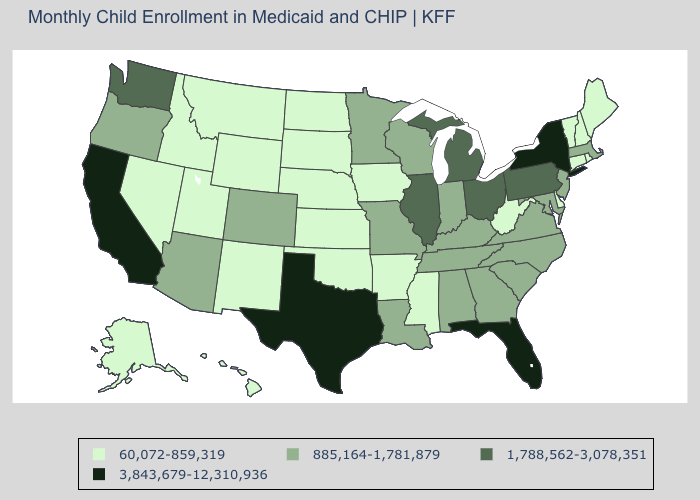What is the value of Minnesota?
Keep it brief. 885,164-1,781,879. Which states have the lowest value in the USA?
Short answer required. Alaska, Arkansas, Connecticut, Delaware, Hawaii, Idaho, Iowa, Kansas, Maine, Mississippi, Montana, Nebraska, Nevada, New Hampshire, New Mexico, North Dakota, Oklahoma, Rhode Island, South Dakota, Utah, Vermont, West Virginia, Wyoming. How many symbols are there in the legend?
Be succinct. 4. What is the value of Arkansas?
Write a very short answer. 60,072-859,319. What is the highest value in states that border Rhode Island?
Concise answer only. 885,164-1,781,879. Is the legend a continuous bar?
Short answer required. No. Does Mississippi have the lowest value in the USA?
Short answer required. Yes. Name the states that have a value in the range 1,788,562-3,078,351?
Be succinct. Illinois, Michigan, Ohio, Pennsylvania, Washington. What is the value of Nevada?
Concise answer only. 60,072-859,319. How many symbols are there in the legend?
Keep it brief. 4. What is the value of Minnesota?
Short answer required. 885,164-1,781,879. What is the highest value in states that border Arkansas?
Keep it brief. 3,843,679-12,310,936. What is the lowest value in states that border Montana?
Give a very brief answer. 60,072-859,319. Among the states that border Wisconsin , which have the highest value?
Give a very brief answer. Illinois, Michigan. How many symbols are there in the legend?
Concise answer only. 4. 